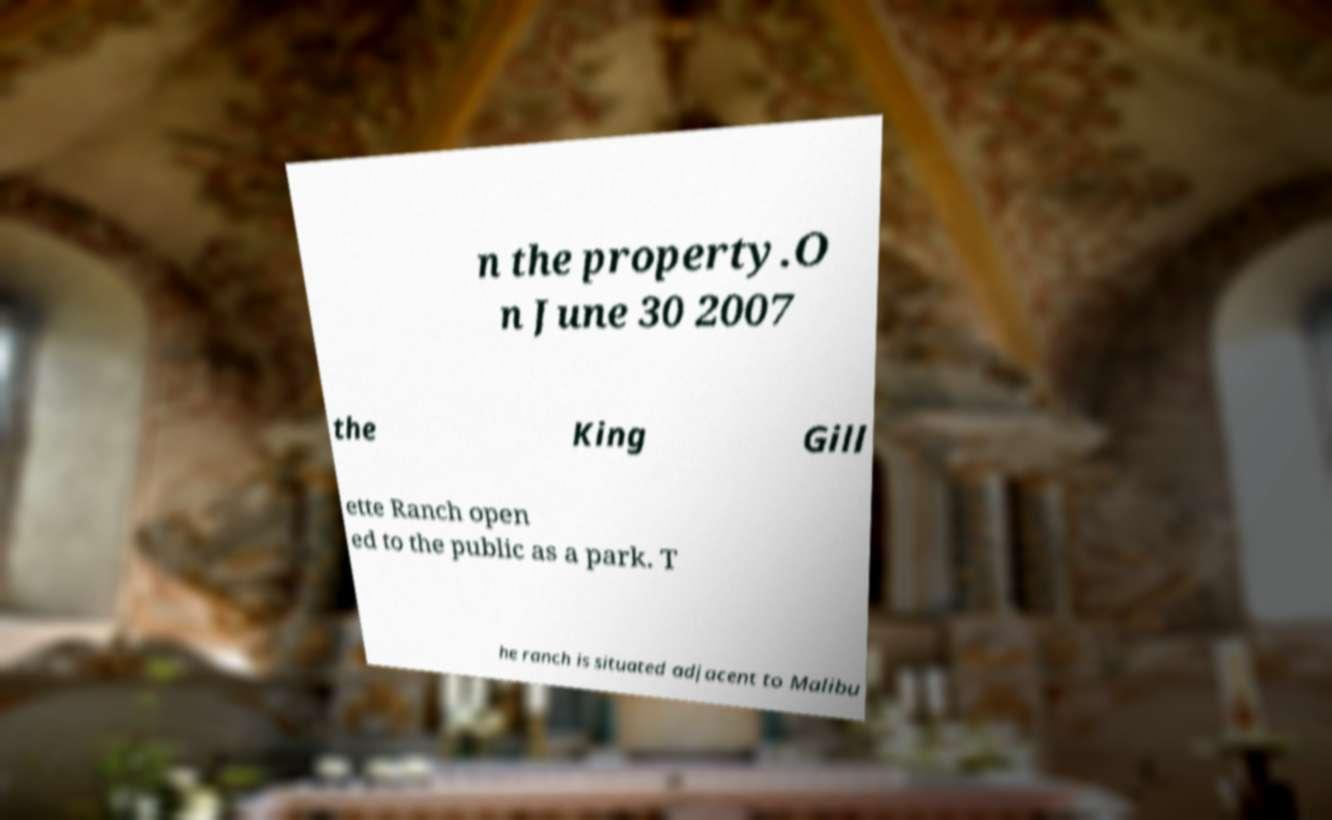Can you accurately transcribe the text from the provided image for me? n the property.O n June 30 2007 the King Gill ette Ranch open ed to the public as a park. T he ranch is situated adjacent to Malibu 